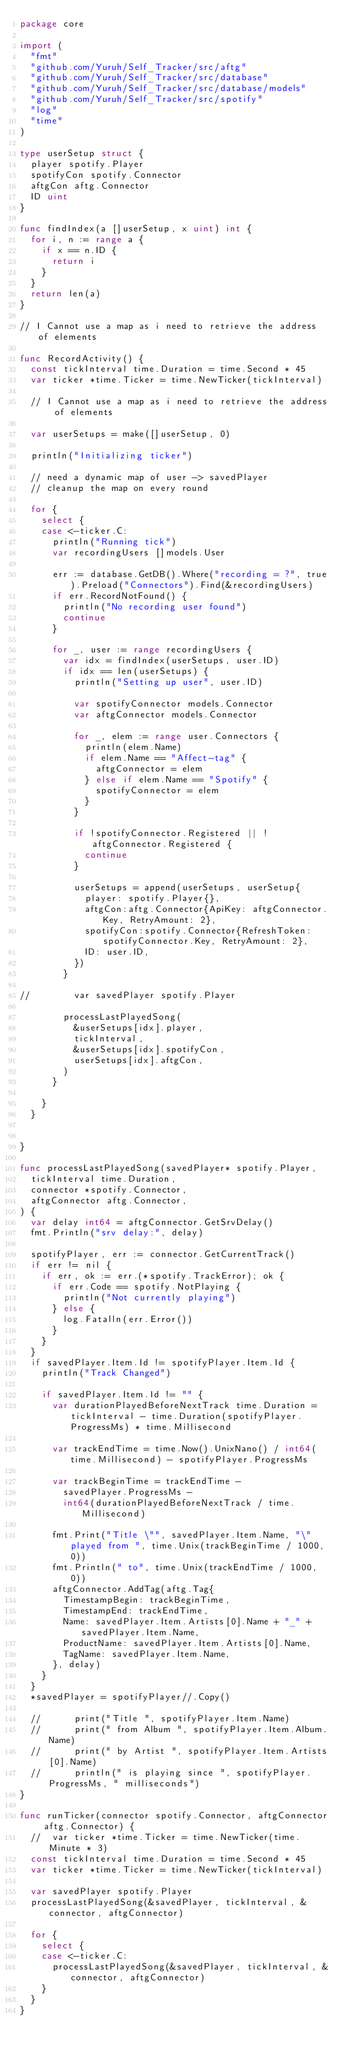<code> <loc_0><loc_0><loc_500><loc_500><_Go_>package core

import (
	"fmt"
	"github.com/Yuruh/Self_Tracker/src/aftg"
	"github.com/Yuruh/Self_Tracker/src/database"
	"github.com/Yuruh/Self_Tracker/src/database/models"
	"github.com/Yuruh/Self_Tracker/src/spotify"
	"log"
	"time"
)

type userSetup struct {
	player spotify.Player
	spotifyCon spotify.Connector
	aftgCon aftg.Connector
	ID uint
}

func findIndex(a []userSetup, x uint) int {
	for i, n := range a {
		if x == n.ID {
			return i
		}
	}
	return len(a)
}

// I Cannot use a map as i need to retrieve the address of elements

func RecordActivity() {
	const tickInterval time.Duration = time.Second * 45
	var ticker *time.Ticker = time.NewTicker(tickInterval)

	// I Cannot use a map as i need to retrieve the address of elements

	var userSetups = make([]userSetup, 0)

	println("Initializing ticker")

	// need a dynamic map of user -> savedPlayer
	// cleanup the map on every round

	for {
		select {
		case <-ticker.C:
			println("Running tick")
			var recordingUsers []models.User

			err := database.GetDB().Where("recording = ?", true).Preload("Connectors").Find(&recordingUsers)
			if err.RecordNotFound() {
				println("No recording user found")
				continue
			}

			for _, user := range recordingUsers {
				var idx = findIndex(userSetups, user.ID)
				if idx == len(userSetups) {
					println("Setting up user", user.ID)

					var spotifyConnector models.Connector
					var aftgConnector models.Connector

					for _, elem := range user.Connectors {
						println(elem.Name)
						if elem.Name == "Affect-tag" {
							aftgConnector = elem
						} else if elem.Name == "Spotify" {
							spotifyConnector = elem
						}
					}

					if !spotifyConnector.Registered || ! aftgConnector.Registered {
						continue
					}

					userSetups = append(userSetups, userSetup{
						player: spotify.Player{},
						aftgCon:aftg.Connector{ApiKey: aftgConnector.Key, RetryAmount: 2},
						spotifyCon:spotify.Connector{RefreshToken: spotifyConnector.Key, RetryAmount: 2},
						ID: user.ID,
					})
				}

//				var savedPlayer spotify.Player

				processLastPlayedSong(
					&userSetups[idx].player,
					tickInterval,
					&userSetups[idx].spotifyCon,
					userSetups[idx].aftgCon,
				)
			}

		}
	}


}

func processLastPlayedSong(savedPlayer* spotify.Player,
	tickInterval time.Duration,
	connector *spotify.Connector,
	aftgConnector aftg.Connector,
) {
	var delay int64 = aftgConnector.GetSrvDelay()
	fmt.Println("srv delay:", delay)

	spotifyPlayer, err := connector.GetCurrentTrack()
	if err != nil {
		if err, ok := err.(*spotify.TrackError); ok {
			if err.Code == spotify.NotPlaying {
				println("Not currently playing")
			} else {
				log.Fatalln(err.Error())
			}
		}
	}
	if savedPlayer.Item.Id != spotifyPlayer.Item.Id {
		println("Track Changed")

		if savedPlayer.Item.Id != "" {
			var durationPlayedBeforeNextTrack time.Duration = tickInterval - time.Duration(spotifyPlayer.ProgressMs) * time.Millisecond

			var trackEndTime = time.Now().UnixNano() / int64(time.Millisecond) - spotifyPlayer.ProgressMs

			var trackBeginTime = trackEndTime -
				savedPlayer.ProgressMs -
				int64(durationPlayedBeforeNextTrack / time.Millisecond)

			fmt.Print("Title \"", savedPlayer.Item.Name, "\" played from ", time.Unix(trackBeginTime / 1000, 0))
			fmt.Println(" to", time.Unix(trackEndTime / 1000, 0))
			aftgConnector.AddTag(aftg.Tag{
				TimestampBegin: trackBeginTime,
				TimestampEnd: trackEndTime,
				Name: savedPlayer.Item.Artists[0].Name + "_" + savedPlayer.Item.Name,
				ProductName: savedPlayer.Item.Artists[0].Name,
				TagName: savedPlayer.Item.Name,
			}, delay)
		}
	}
	*savedPlayer = spotifyPlayer//.Copy()

	//			print("Title ", spotifyPlayer.Item.Name)
	//			print(" from Album ", spotifyPlayer.Item.Album.Name)
	//			print(" by Artist ", spotifyPlayer.Item.Artists[0].Name)
	//			println(" is playing since ", spotifyPlayer.ProgressMs, " milliseconds")
}

func runTicker(connector spotify.Connector, aftgConnector aftg.Connector) {
	//	var ticker *time.Ticker = time.NewTicker(time.Minute * 3)
	const tickInterval time.Duration = time.Second * 45
	var ticker *time.Ticker = time.NewTicker(tickInterval)

	var savedPlayer spotify.Player
	processLastPlayedSong(&savedPlayer, tickInterval, &connector, aftgConnector)

	for {
		select {
		case <-ticker.C:
			processLastPlayedSong(&savedPlayer, tickInterval, &connector, aftgConnector)
		}
	}
}
</code> 